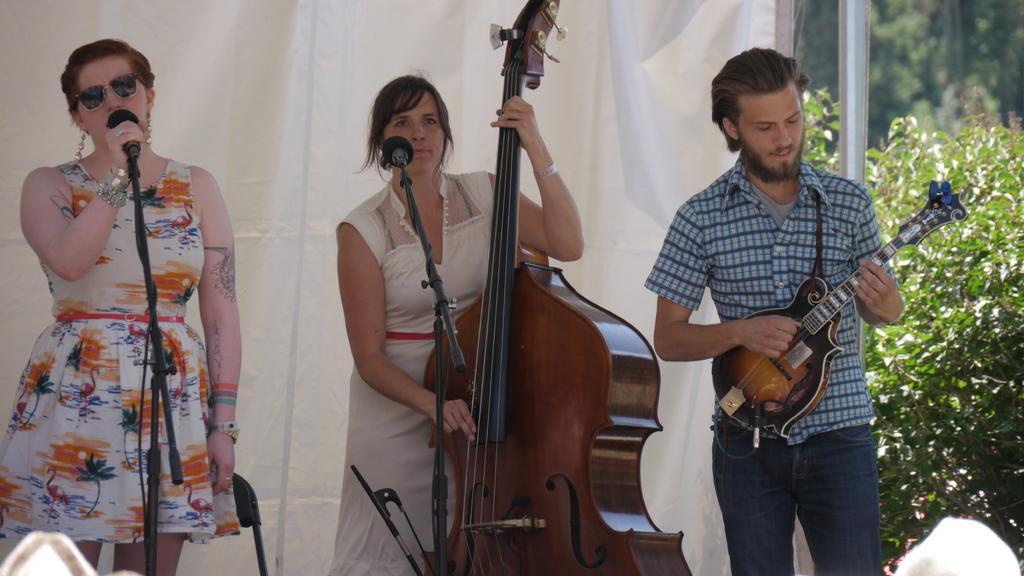How would you summarize this image in a sentence or two? On the left a woman is singing in the microphone. In the middle a woman is playing the guitar in the right a man is also playing the guitar. 